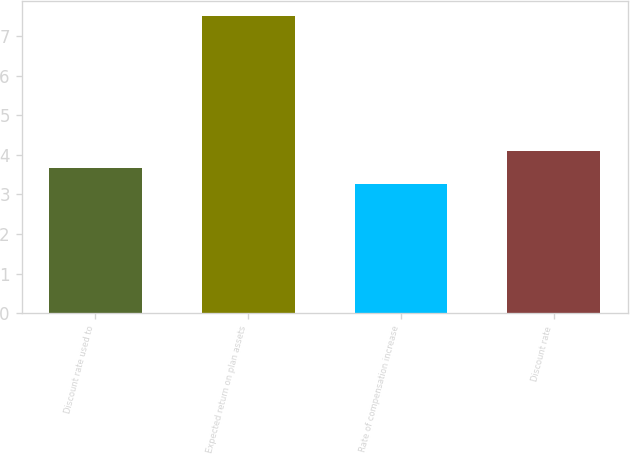Convert chart. <chart><loc_0><loc_0><loc_500><loc_500><bar_chart><fcel>Discount rate used to<fcel>Expected return on plan assets<fcel>Rate of compensation increase<fcel>Discount rate<nl><fcel>3.67<fcel>7.5<fcel>3.25<fcel>4.09<nl></chart> 